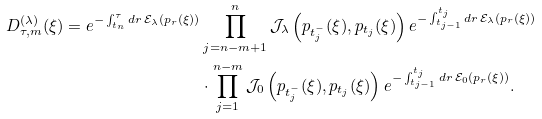Convert formula to latex. <formula><loc_0><loc_0><loc_500><loc_500>D _ { \tau , m } ^ { ( \lambda ) } ( \xi ) = e ^ { - \int _ { t _ { n } } ^ { \tau } d r \, \mathcal { E } _ { \lambda } ( p _ { r } ( \xi ) ) } & \prod _ { j = n - m + 1 } ^ { n } \mathcal { J } _ { \lambda } \left ( p _ { t _ { j } ^ { - } } ( \xi ) , p _ { t _ { j } } ( \xi ) \right ) e ^ { - \int _ { t _ { j - 1 } } ^ { t _ { j } } d r \, \mathcal { E } _ { \lambda } ( p _ { r } ( \xi ) ) } \\ & \cdot \prod _ { j = 1 } ^ { n - m } \mathcal { J } _ { 0 } \left ( p _ { t _ { j } ^ { - } } ( \xi ) , p _ { t _ { j } } ( \xi ) \right ) e ^ { - \int _ { t _ { j - 1 } } ^ { t _ { j } } d r \, \mathcal { E } _ { 0 } ( p _ { r } ( \xi ) ) } .</formula> 